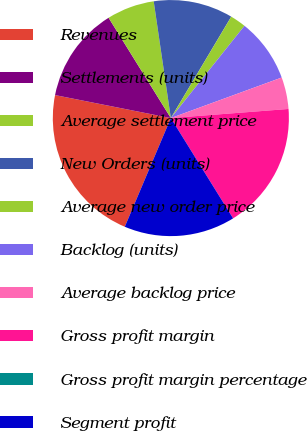Convert chart. <chart><loc_0><loc_0><loc_500><loc_500><pie_chart><fcel>Revenues<fcel>Settlements (units)<fcel>Average settlement price<fcel>New Orders (units)<fcel>Average new order price<fcel>Backlog (units)<fcel>Average backlog price<fcel>Gross profit margin<fcel>Gross profit margin percentage<fcel>Segment profit<nl><fcel>21.74%<fcel>13.04%<fcel>6.52%<fcel>10.87%<fcel>2.17%<fcel>8.7%<fcel>4.35%<fcel>17.39%<fcel>0.0%<fcel>15.22%<nl></chart> 